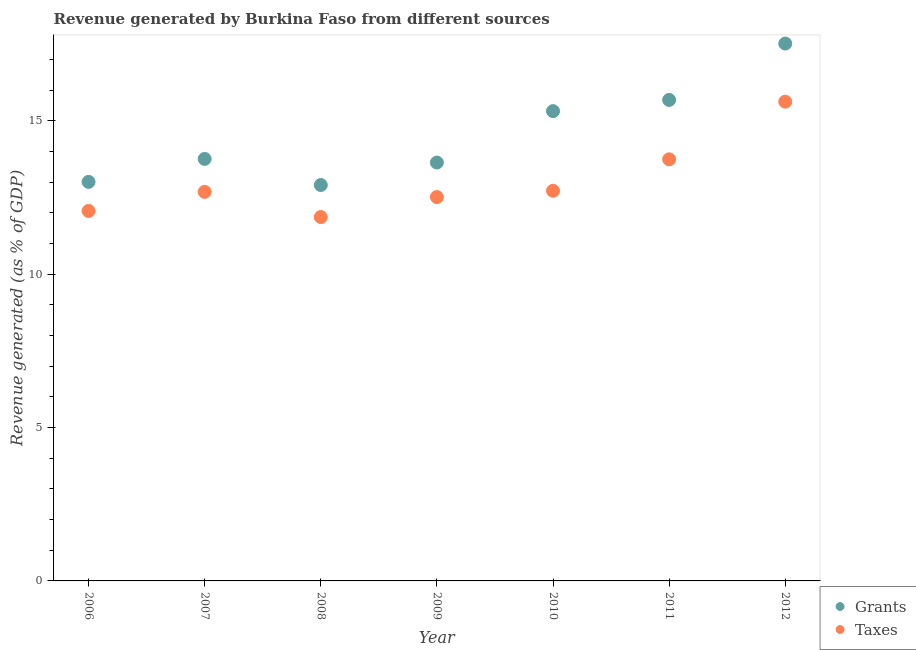What is the revenue generated by taxes in 2012?
Provide a succinct answer. 15.63. Across all years, what is the maximum revenue generated by taxes?
Your response must be concise. 15.63. Across all years, what is the minimum revenue generated by taxes?
Offer a terse response. 11.86. In which year was the revenue generated by grants maximum?
Give a very brief answer. 2012. In which year was the revenue generated by taxes minimum?
Your answer should be very brief. 2008. What is the total revenue generated by grants in the graph?
Offer a very short reply. 101.84. What is the difference between the revenue generated by taxes in 2006 and that in 2007?
Provide a short and direct response. -0.62. What is the difference between the revenue generated by taxes in 2006 and the revenue generated by grants in 2009?
Provide a short and direct response. -1.58. What is the average revenue generated by grants per year?
Provide a short and direct response. 14.55. In the year 2012, what is the difference between the revenue generated by grants and revenue generated by taxes?
Your answer should be compact. 1.9. What is the ratio of the revenue generated by grants in 2007 to that in 2008?
Make the answer very short. 1.07. Is the difference between the revenue generated by grants in 2006 and 2009 greater than the difference between the revenue generated by taxes in 2006 and 2009?
Offer a very short reply. No. What is the difference between the highest and the second highest revenue generated by grants?
Provide a succinct answer. 1.84. What is the difference between the highest and the lowest revenue generated by grants?
Make the answer very short. 4.61. In how many years, is the revenue generated by taxes greater than the average revenue generated by taxes taken over all years?
Keep it short and to the point. 2. Does the revenue generated by taxes monotonically increase over the years?
Offer a very short reply. No. Is the revenue generated by grants strictly greater than the revenue generated by taxes over the years?
Give a very brief answer. Yes. Is the revenue generated by taxes strictly less than the revenue generated by grants over the years?
Offer a terse response. Yes. What is the difference between two consecutive major ticks on the Y-axis?
Give a very brief answer. 5. Does the graph contain any zero values?
Give a very brief answer. No. How are the legend labels stacked?
Your answer should be compact. Vertical. What is the title of the graph?
Ensure brevity in your answer.  Revenue generated by Burkina Faso from different sources. What is the label or title of the X-axis?
Give a very brief answer. Year. What is the label or title of the Y-axis?
Make the answer very short. Revenue generated (as % of GDP). What is the Revenue generated (as % of GDP) in Grants in 2006?
Your response must be concise. 13.01. What is the Revenue generated (as % of GDP) of Taxes in 2006?
Offer a very short reply. 12.06. What is the Revenue generated (as % of GDP) of Grants in 2007?
Make the answer very short. 13.76. What is the Revenue generated (as % of GDP) in Taxes in 2007?
Your answer should be compact. 12.69. What is the Revenue generated (as % of GDP) in Grants in 2008?
Make the answer very short. 12.91. What is the Revenue generated (as % of GDP) in Taxes in 2008?
Offer a terse response. 11.86. What is the Revenue generated (as % of GDP) of Grants in 2009?
Ensure brevity in your answer.  13.64. What is the Revenue generated (as % of GDP) in Taxes in 2009?
Provide a succinct answer. 12.52. What is the Revenue generated (as % of GDP) in Grants in 2010?
Offer a terse response. 15.32. What is the Revenue generated (as % of GDP) in Taxes in 2010?
Offer a very short reply. 12.72. What is the Revenue generated (as % of GDP) of Grants in 2011?
Provide a short and direct response. 15.68. What is the Revenue generated (as % of GDP) of Taxes in 2011?
Keep it short and to the point. 13.75. What is the Revenue generated (as % of GDP) in Grants in 2012?
Your answer should be very brief. 17.52. What is the Revenue generated (as % of GDP) in Taxes in 2012?
Offer a very short reply. 15.63. Across all years, what is the maximum Revenue generated (as % of GDP) in Grants?
Keep it short and to the point. 17.52. Across all years, what is the maximum Revenue generated (as % of GDP) of Taxes?
Your answer should be compact. 15.63. Across all years, what is the minimum Revenue generated (as % of GDP) of Grants?
Provide a short and direct response. 12.91. Across all years, what is the minimum Revenue generated (as % of GDP) of Taxes?
Provide a short and direct response. 11.86. What is the total Revenue generated (as % of GDP) in Grants in the graph?
Give a very brief answer. 101.84. What is the total Revenue generated (as % of GDP) in Taxes in the graph?
Your answer should be compact. 91.22. What is the difference between the Revenue generated (as % of GDP) in Grants in 2006 and that in 2007?
Offer a very short reply. -0.75. What is the difference between the Revenue generated (as % of GDP) in Taxes in 2006 and that in 2007?
Provide a short and direct response. -0.62. What is the difference between the Revenue generated (as % of GDP) of Grants in 2006 and that in 2008?
Ensure brevity in your answer.  0.1. What is the difference between the Revenue generated (as % of GDP) in Taxes in 2006 and that in 2008?
Make the answer very short. 0.2. What is the difference between the Revenue generated (as % of GDP) in Grants in 2006 and that in 2009?
Your answer should be very brief. -0.63. What is the difference between the Revenue generated (as % of GDP) in Taxes in 2006 and that in 2009?
Provide a short and direct response. -0.45. What is the difference between the Revenue generated (as % of GDP) in Grants in 2006 and that in 2010?
Give a very brief answer. -2.31. What is the difference between the Revenue generated (as % of GDP) of Taxes in 2006 and that in 2010?
Keep it short and to the point. -0.66. What is the difference between the Revenue generated (as % of GDP) of Grants in 2006 and that in 2011?
Give a very brief answer. -2.67. What is the difference between the Revenue generated (as % of GDP) in Taxes in 2006 and that in 2011?
Offer a very short reply. -1.68. What is the difference between the Revenue generated (as % of GDP) in Grants in 2006 and that in 2012?
Your answer should be very brief. -4.51. What is the difference between the Revenue generated (as % of GDP) in Taxes in 2006 and that in 2012?
Your answer should be compact. -3.56. What is the difference between the Revenue generated (as % of GDP) of Grants in 2007 and that in 2008?
Your answer should be compact. 0.85. What is the difference between the Revenue generated (as % of GDP) of Taxes in 2007 and that in 2008?
Your response must be concise. 0.82. What is the difference between the Revenue generated (as % of GDP) in Grants in 2007 and that in 2009?
Provide a short and direct response. 0.12. What is the difference between the Revenue generated (as % of GDP) in Taxes in 2007 and that in 2009?
Offer a terse response. 0.17. What is the difference between the Revenue generated (as % of GDP) of Grants in 2007 and that in 2010?
Provide a short and direct response. -1.56. What is the difference between the Revenue generated (as % of GDP) in Taxes in 2007 and that in 2010?
Offer a terse response. -0.03. What is the difference between the Revenue generated (as % of GDP) of Grants in 2007 and that in 2011?
Offer a very short reply. -1.92. What is the difference between the Revenue generated (as % of GDP) in Taxes in 2007 and that in 2011?
Give a very brief answer. -1.06. What is the difference between the Revenue generated (as % of GDP) in Grants in 2007 and that in 2012?
Offer a terse response. -3.76. What is the difference between the Revenue generated (as % of GDP) in Taxes in 2007 and that in 2012?
Your answer should be compact. -2.94. What is the difference between the Revenue generated (as % of GDP) in Grants in 2008 and that in 2009?
Your answer should be compact. -0.73. What is the difference between the Revenue generated (as % of GDP) in Taxes in 2008 and that in 2009?
Make the answer very short. -0.65. What is the difference between the Revenue generated (as % of GDP) of Grants in 2008 and that in 2010?
Your answer should be compact. -2.41. What is the difference between the Revenue generated (as % of GDP) of Taxes in 2008 and that in 2010?
Provide a short and direct response. -0.86. What is the difference between the Revenue generated (as % of GDP) of Grants in 2008 and that in 2011?
Your response must be concise. -2.77. What is the difference between the Revenue generated (as % of GDP) in Taxes in 2008 and that in 2011?
Give a very brief answer. -1.88. What is the difference between the Revenue generated (as % of GDP) of Grants in 2008 and that in 2012?
Your answer should be compact. -4.61. What is the difference between the Revenue generated (as % of GDP) in Taxes in 2008 and that in 2012?
Offer a terse response. -3.76. What is the difference between the Revenue generated (as % of GDP) in Grants in 2009 and that in 2010?
Your answer should be compact. -1.68. What is the difference between the Revenue generated (as % of GDP) of Taxes in 2009 and that in 2010?
Offer a terse response. -0.21. What is the difference between the Revenue generated (as % of GDP) of Grants in 2009 and that in 2011?
Keep it short and to the point. -2.04. What is the difference between the Revenue generated (as % of GDP) of Taxes in 2009 and that in 2011?
Offer a terse response. -1.23. What is the difference between the Revenue generated (as % of GDP) of Grants in 2009 and that in 2012?
Offer a very short reply. -3.88. What is the difference between the Revenue generated (as % of GDP) in Taxes in 2009 and that in 2012?
Make the answer very short. -3.11. What is the difference between the Revenue generated (as % of GDP) in Grants in 2010 and that in 2011?
Provide a succinct answer. -0.37. What is the difference between the Revenue generated (as % of GDP) of Taxes in 2010 and that in 2011?
Give a very brief answer. -1.03. What is the difference between the Revenue generated (as % of GDP) of Grants in 2010 and that in 2012?
Your answer should be very brief. -2.2. What is the difference between the Revenue generated (as % of GDP) in Taxes in 2010 and that in 2012?
Ensure brevity in your answer.  -2.91. What is the difference between the Revenue generated (as % of GDP) of Grants in 2011 and that in 2012?
Provide a succinct answer. -1.84. What is the difference between the Revenue generated (as % of GDP) of Taxes in 2011 and that in 2012?
Offer a terse response. -1.88. What is the difference between the Revenue generated (as % of GDP) of Grants in 2006 and the Revenue generated (as % of GDP) of Taxes in 2007?
Ensure brevity in your answer.  0.32. What is the difference between the Revenue generated (as % of GDP) of Grants in 2006 and the Revenue generated (as % of GDP) of Taxes in 2008?
Your answer should be very brief. 1.15. What is the difference between the Revenue generated (as % of GDP) of Grants in 2006 and the Revenue generated (as % of GDP) of Taxes in 2009?
Make the answer very short. 0.5. What is the difference between the Revenue generated (as % of GDP) in Grants in 2006 and the Revenue generated (as % of GDP) in Taxes in 2010?
Keep it short and to the point. 0.29. What is the difference between the Revenue generated (as % of GDP) of Grants in 2006 and the Revenue generated (as % of GDP) of Taxes in 2011?
Your answer should be very brief. -0.74. What is the difference between the Revenue generated (as % of GDP) in Grants in 2006 and the Revenue generated (as % of GDP) in Taxes in 2012?
Ensure brevity in your answer.  -2.62. What is the difference between the Revenue generated (as % of GDP) in Grants in 2007 and the Revenue generated (as % of GDP) in Taxes in 2008?
Your answer should be very brief. 1.9. What is the difference between the Revenue generated (as % of GDP) of Grants in 2007 and the Revenue generated (as % of GDP) of Taxes in 2009?
Offer a terse response. 1.24. What is the difference between the Revenue generated (as % of GDP) in Grants in 2007 and the Revenue generated (as % of GDP) in Taxes in 2010?
Offer a terse response. 1.04. What is the difference between the Revenue generated (as % of GDP) of Grants in 2007 and the Revenue generated (as % of GDP) of Taxes in 2011?
Keep it short and to the point. 0.01. What is the difference between the Revenue generated (as % of GDP) in Grants in 2007 and the Revenue generated (as % of GDP) in Taxes in 2012?
Give a very brief answer. -1.87. What is the difference between the Revenue generated (as % of GDP) in Grants in 2008 and the Revenue generated (as % of GDP) in Taxes in 2009?
Your answer should be compact. 0.39. What is the difference between the Revenue generated (as % of GDP) of Grants in 2008 and the Revenue generated (as % of GDP) of Taxes in 2010?
Offer a very short reply. 0.19. What is the difference between the Revenue generated (as % of GDP) in Grants in 2008 and the Revenue generated (as % of GDP) in Taxes in 2011?
Give a very brief answer. -0.84. What is the difference between the Revenue generated (as % of GDP) of Grants in 2008 and the Revenue generated (as % of GDP) of Taxes in 2012?
Make the answer very short. -2.72. What is the difference between the Revenue generated (as % of GDP) in Grants in 2009 and the Revenue generated (as % of GDP) in Taxes in 2010?
Provide a short and direct response. 0.92. What is the difference between the Revenue generated (as % of GDP) in Grants in 2009 and the Revenue generated (as % of GDP) in Taxes in 2011?
Make the answer very short. -0.11. What is the difference between the Revenue generated (as % of GDP) of Grants in 2009 and the Revenue generated (as % of GDP) of Taxes in 2012?
Your answer should be very brief. -1.98. What is the difference between the Revenue generated (as % of GDP) in Grants in 2010 and the Revenue generated (as % of GDP) in Taxes in 2011?
Your answer should be very brief. 1.57. What is the difference between the Revenue generated (as % of GDP) in Grants in 2010 and the Revenue generated (as % of GDP) in Taxes in 2012?
Give a very brief answer. -0.31. What is the difference between the Revenue generated (as % of GDP) of Grants in 2011 and the Revenue generated (as % of GDP) of Taxes in 2012?
Give a very brief answer. 0.06. What is the average Revenue generated (as % of GDP) in Grants per year?
Offer a terse response. 14.55. What is the average Revenue generated (as % of GDP) in Taxes per year?
Your response must be concise. 13.03. In the year 2006, what is the difference between the Revenue generated (as % of GDP) of Grants and Revenue generated (as % of GDP) of Taxes?
Provide a short and direct response. 0.95. In the year 2007, what is the difference between the Revenue generated (as % of GDP) in Grants and Revenue generated (as % of GDP) in Taxes?
Ensure brevity in your answer.  1.07. In the year 2008, what is the difference between the Revenue generated (as % of GDP) of Grants and Revenue generated (as % of GDP) of Taxes?
Make the answer very short. 1.04. In the year 2009, what is the difference between the Revenue generated (as % of GDP) in Grants and Revenue generated (as % of GDP) in Taxes?
Give a very brief answer. 1.13. In the year 2010, what is the difference between the Revenue generated (as % of GDP) in Grants and Revenue generated (as % of GDP) in Taxes?
Offer a very short reply. 2.6. In the year 2011, what is the difference between the Revenue generated (as % of GDP) in Grants and Revenue generated (as % of GDP) in Taxes?
Your answer should be very brief. 1.94. In the year 2012, what is the difference between the Revenue generated (as % of GDP) in Grants and Revenue generated (as % of GDP) in Taxes?
Make the answer very short. 1.9. What is the ratio of the Revenue generated (as % of GDP) in Grants in 2006 to that in 2007?
Give a very brief answer. 0.95. What is the ratio of the Revenue generated (as % of GDP) in Taxes in 2006 to that in 2007?
Provide a short and direct response. 0.95. What is the ratio of the Revenue generated (as % of GDP) of Grants in 2006 to that in 2008?
Keep it short and to the point. 1.01. What is the ratio of the Revenue generated (as % of GDP) of Taxes in 2006 to that in 2008?
Your answer should be compact. 1.02. What is the ratio of the Revenue generated (as % of GDP) of Grants in 2006 to that in 2009?
Offer a very short reply. 0.95. What is the ratio of the Revenue generated (as % of GDP) of Taxes in 2006 to that in 2009?
Provide a succinct answer. 0.96. What is the ratio of the Revenue generated (as % of GDP) of Grants in 2006 to that in 2010?
Your answer should be compact. 0.85. What is the ratio of the Revenue generated (as % of GDP) in Taxes in 2006 to that in 2010?
Give a very brief answer. 0.95. What is the ratio of the Revenue generated (as % of GDP) in Grants in 2006 to that in 2011?
Give a very brief answer. 0.83. What is the ratio of the Revenue generated (as % of GDP) of Taxes in 2006 to that in 2011?
Ensure brevity in your answer.  0.88. What is the ratio of the Revenue generated (as % of GDP) in Grants in 2006 to that in 2012?
Ensure brevity in your answer.  0.74. What is the ratio of the Revenue generated (as % of GDP) in Taxes in 2006 to that in 2012?
Make the answer very short. 0.77. What is the ratio of the Revenue generated (as % of GDP) in Grants in 2007 to that in 2008?
Offer a very short reply. 1.07. What is the ratio of the Revenue generated (as % of GDP) in Taxes in 2007 to that in 2008?
Your response must be concise. 1.07. What is the ratio of the Revenue generated (as % of GDP) in Grants in 2007 to that in 2009?
Your response must be concise. 1.01. What is the ratio of the Revenue generated (as % of GDP) in Taxes in 2007 to that in 2009?
Your response must be concise. 1.01. What is the ratio of the Revenue generated (as % of GDP) in Grants in 2007 to that in 2010?
Make the answer very short. 0.9. What is the ratio of the Revenue generated (as % of GDP) in Taxes in 2007 to that in 2010?
Your response must be concise. 1. What is the ratio of the Revenue generated (as % of GDP) of Grants in 2007 to that in 2011?
Offer a very short reply. 0.88. What is the ratio of the Revenue generated (as % of GDP) of Taxes in 2007 to that in 2011?
Ensure brevity in your answer.  0.92. What is the ratio of the Revenue generated (as % of GDP) of Grants in 2007 to that in 2012?
Offer a very short reply. 0.79. What is the ratio of the Revenue generated (as % of GDP) in Taxes in 2007 to that in 2012?
Your response must be concise. 0.81. What is the ratio of the Revenue generated (as % of GDP) of Grants in 2008 to that in 2009?
Offer a terse response. 0.95. What is the ratio of the Revenue generated (as % of GDP) of Taxes in 2008 to that in 2009?
Keep it short and to the point. 0.95. What is the ratio of the Revenue generated (as % of GDP) in Grants in 2008 to that in 2010?
Provide a succinct answer. 0.84. What is the ratio of the Revenue generated (as % of GDP) in Taxes in 2008 to that in 2010?
Your answer should be very brief. 0.93. What is the ratio of the Revenue generated (as % of GDP) in Grants in 2008 to that in 2011?
Keep it short and to the point. 0.82. What is the ratio of the Revenue generated (as % of GDP) in Taxes in 2008 to that in 2011?
Offer a terse response. 0.86. What is the ratio of the Revenue generated (as % of GDP) in Grants in 2008 to that in 2012?
Provide a short and direct response. 0.74. What is the ratio of the Revenue generated (as % of GDP) of Taxes in 2008 to that in 2012?
Offer a very short reply. 0.76. What is the ratio of the Revenue generated (as % of GDP) of Grants in 2009 to that in 2010?
Offer a terse response. 0.89. What is the ratio of the Revenue generated (as % of GDP) of Taxes in 2009 to that in 2010?
Provide a succinct answer. 0.98. What is the ratio of the Revenue generated (as % of GDP) of Grants in 2009 to that in 2011?
Keep it short and to the point. 0.87. What is the ratio of the Revenue generated (as % of GDP) of Taxes in 2009 to that in 2011?
Provide a succinct answer. 0.91. What is the ratio of the Revenue generated (as % of GDP) in Grants in 2009 to that in 2012?
Ensure brevity in your answer.  0.78. What is the ratio of the Revenue generated (as % of GDP) in Taxes in 2009 to that in 2012?
Give a very brief answer. 0.8. What is the ratio of the Revenue generated (as % of GDP) in Grants in 2010 to that in 2011?
Your answer should be compact. 0.98. What is the ratio of the Revenue generated (as % of GDP) in Taxes in 2010 to that in 2011?
Give a very brief answer. 0.93. What is the ratio of the Revenue generated (as % of GDP) of Grants in 2010 to that in 2012?
Offer a very short reply. 0.87. What is the ratio of the Revenue generated (as % of GDP) of Taxes in 2010 to that in 2012?
Provide a succinct answer. 0.81. What is the ratio of the Revenue generated (as % of GDP) of Grants in 2011 to that in 2012?
Offer a terse response. 0.9. What is the ratio of the Revenue generated (as % of GDP) of Taxes in 2011 to that in 2012?
Your answer should be compact. 0.88. What is the difference between the highest and the second highest Revenue generated (as % of GDP) in Grants?
Provide a succinct answer. 1.84. What is the difference between the highest and the second highest Revenue generated (as % of GDP) in Taxes?
Make the answer very short. 1.88. What is the difference between the highest and the lowest Revenue generated (as % of GDP) of Grants?
Your answer should be compact. 4.61. What is the difference between the highest and the lowest Revenue generated (as % of GDP) of Taxes?
Provide a succinct answer. 3.76. 